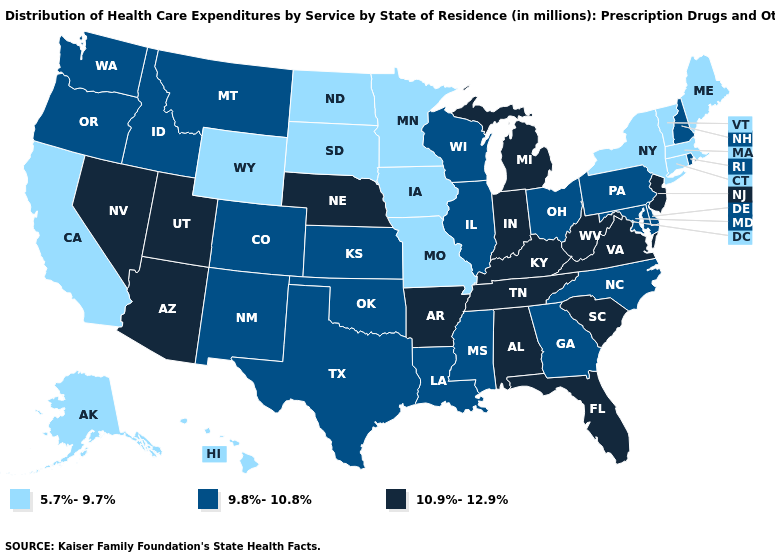What is the lowest value in states that border New Jersey?
Concise answer only. 5.7%-9.7%. Does Minnesota have the lowest value in the USA?
Short answer required. Yes. Which states have the lowest value in the USA?
Concise answer only. Alaska, California, Connecticut, Hawaii, Iowa, Maine, Massachusetts, Minnesota, Missouri, New York, North Dakota, South Dakota, Vermont, Wyoming. What is the value of California?
Short answer required. 5.7%-9.7%. Among the states that border New Mexico , which have the highest value?
Write a very short answer. Arizona, Utah. Name the states that have a value in the range 10.9%-12.9%?
Concise answer only. Alabama, Arizona, Arkansas, Florida, Indiana, Kentucky, Michigan, Nebraska, Nevada, New Jersey, South Carolina, Tennessee, Utah, Virginia, West Virginia. Name the states that have a value in the range 5.7%-9.7%?
Quick response, please. Alaska, California, Connecticut, Hawaii, Iowa, Maine, Massachusetts, Minnesota, Missouri, New York, North Dakota, South Dakota, Vermont, Wyoming. Does Washington have the same value as Michigan?
Be succinct. No. What is the value of Rhode Island?
Answer briefly. 9.8%-10.8%. What is the value of Georgia?
Be succinct. 9.8%-10.8%. What is the highest value in the MidWest ?
Write a very short answer. 10.9%-12.9%. What is the value of Wyoming?
Write a very short answer. 5.7%-9.7%. What is the value of Maine?
Write a very short answer. 5.7%-9.7%. Does the first symbol in the legend represent the smallest category?
Answer briefly. Yes. Name the states that have a value in the range 10.9%-12.9%?
Write a very short answer. Alabama, Arizona, Arkansas, Florida, Indiana, Kentucky, Michigan, Nebraska, Nevada, New Jersey, South Carolina, Tennessee, Utah, Virginia, West Virginia. 